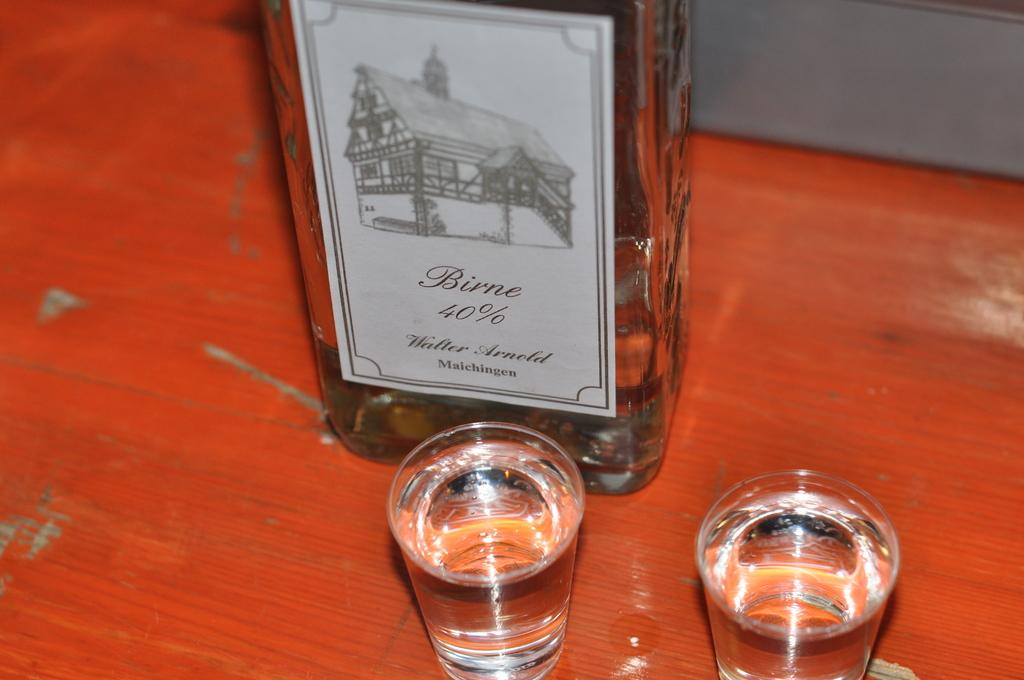<image>
Describe the image concisely. Two shot glasses full of liqour called Birne 